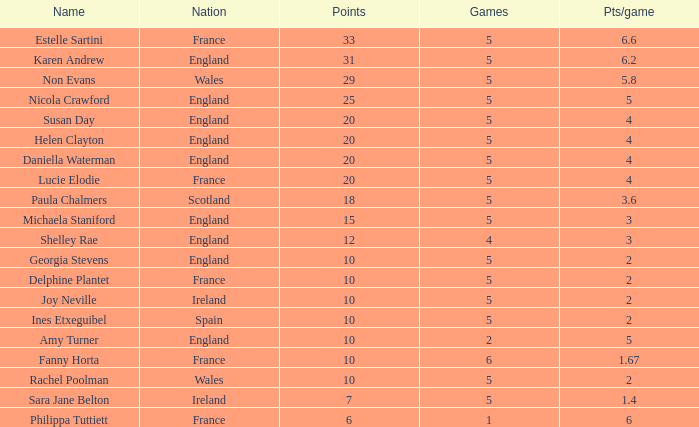Can you inform me of the smallest pts/game with the name of philippa tuttiett and points greater than 6? None. 